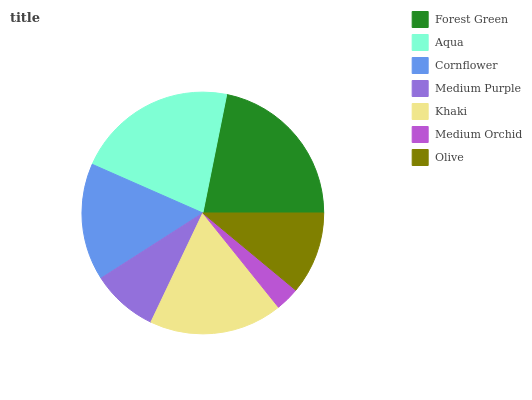Is Medium Orchid the minimum?
Answer yes or no. Yes. Is Forest Green the maximum?
Answer yes or no. Yes. Is Aqua the minimum?
Answer yes or no. No. Is Aqua the maximum?
Answer yes or no. No. Is Forest Green greater than Aqua?
Answer yes or no. Yes. Is Aqua less than Forest Green?
Answer yes or no. Yes. Is Aqua greater than Forest Green?
Answer yes or no. No. Is Forest Green less than Aqua?
Answer yes or no. No. Is Cornflower the high median?
Answer yes or no. Yes. Is Cornflower the low median?
Answer yes or no. Yes. Is Aqua the high median?
Answer yes or no. No. Is Aqua the low median?
Answer yes or no. No. 